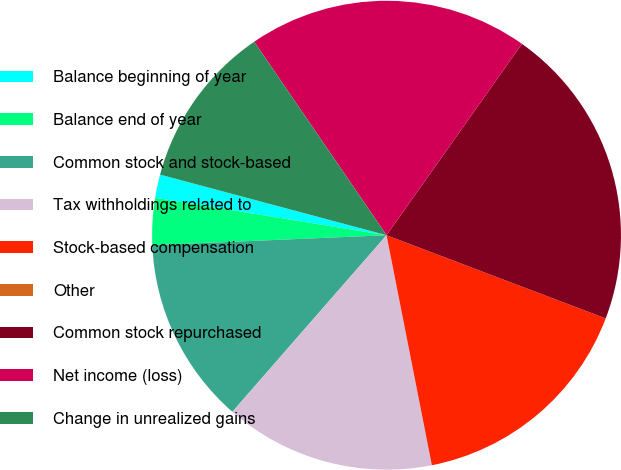Convert chart to OTSL. <chart><loc_0><loc_0><loc_500><loc_500><pie_chart><fcel>Balance beginning of year<fcel>Balance end of year<fcel>Common stock and stock-based<fcel>Tax withholdings related to<fcel>Stock-based compensation<fcel>Other<fcel>Common stock repurchased<fcel>Net income (loss)<fcel>Change in unrealized gains<nl><fcel>1.61%<fcel>3.23%<fcel>12.9%<fcel>14.52%<fcel>16.13%<fcel>0.0%<fcel>20.97%<fcel>19.35%<fcel>11.29%<nl></chart> 